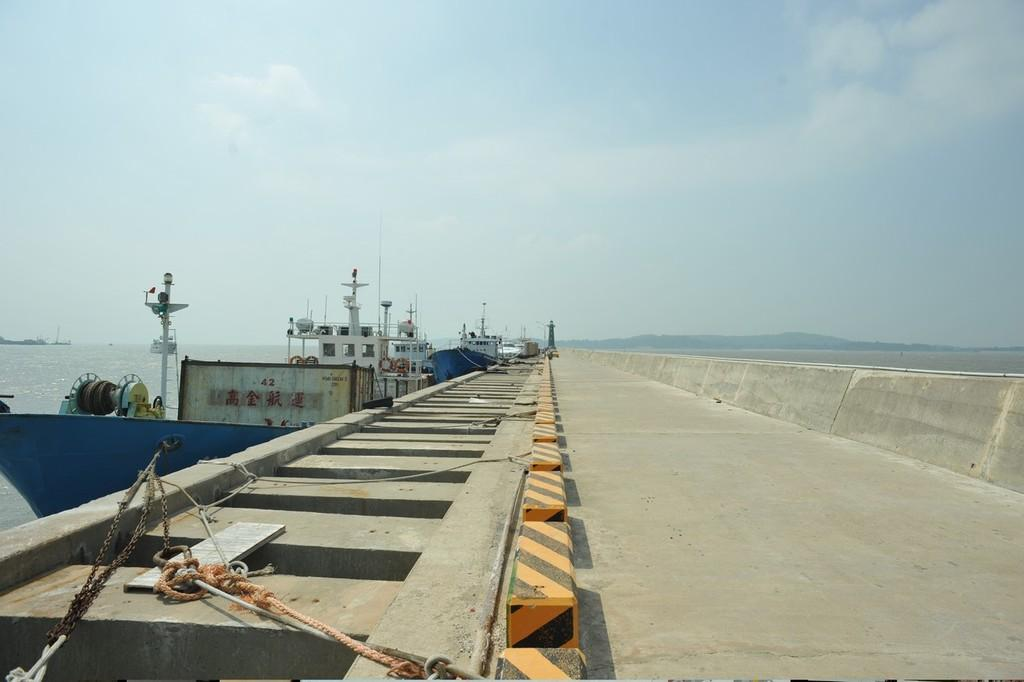What is the main setting of the image? There is a dockyard in the image. What type of vehicle can be seen in the dockyard? There is a ship in the dockyard. What type of road is present in the image? There is a road with bricks in the image. What is visible in the background of the image? The sky is visible in the image. What type of distribution system is present in the image? There is no distribution system present in the image; it features a dockyard, a ship, a brick road, and the sky. What type of guide is visible in the image? There is no guide present in the image. 